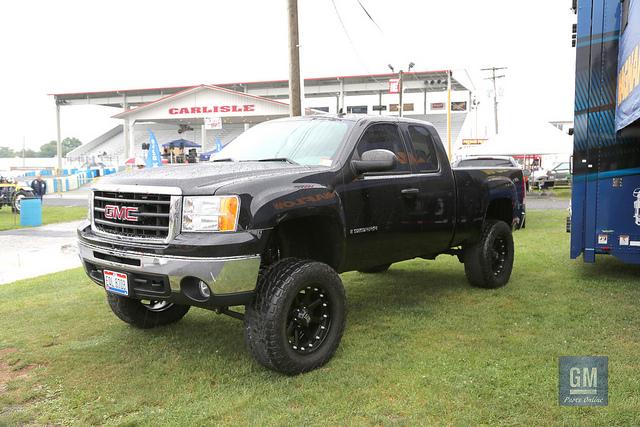Which manufacturer made this truck?
Answer briefly. Gmc. How many cylinders does this truck likely have?
Give a very brief answer. 8. What color are the rims?
Short answer required. Black. 